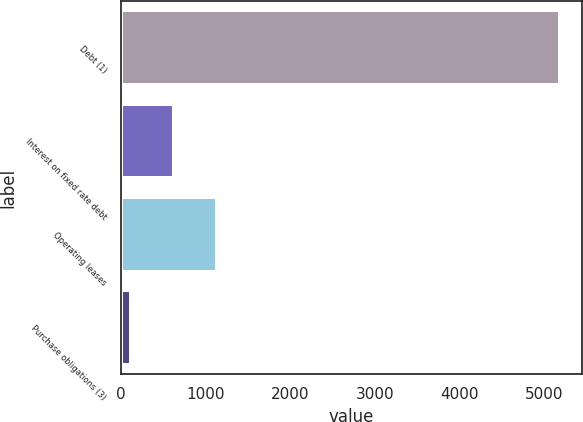Convert chart. <chart><loc_0><loc_0><loc_500><loc_500><bar_chart><fcel>Debt (1)<fcel>Interest on fixed rate debt<fcel>Operating leases<fcel>Purchase obligations (3)<nl><fcel>5191<fcel>623.5<fcel>1131<fcel>116<nl></chart> 